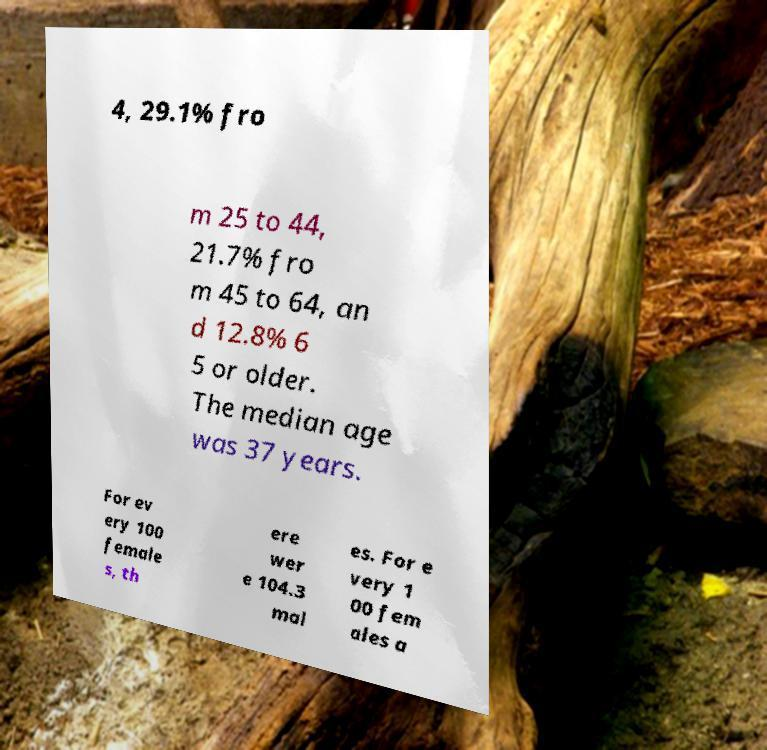Please identify and transcribe the text found in this image. 4, 29.1% fro m 25 to 44, 21.7% fro m 45 to 64, an d 12.8% 6 5 or older. The median age was 37 years. For ev ery 100 female s, th ere wer e 104.3 mal es. For e very 1 00 fem ales a 